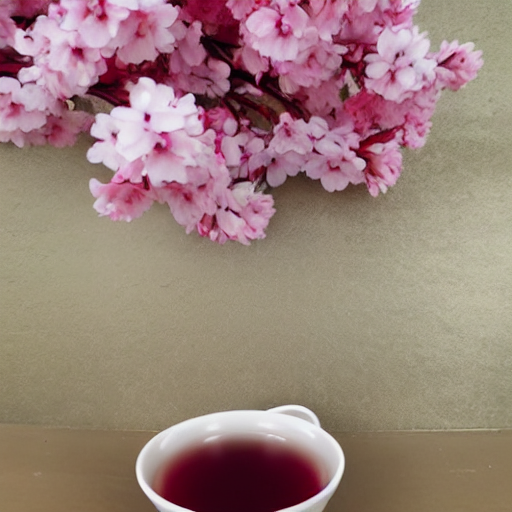What kind of flowers are these, and do they symbolize anything? The flowers in the image appear to be cherry blossoms. In various cultures, particularly in Japan, cherry blossoms symbolize the transient nature of life, as they bloom brilliantly but only for a short duration. Why might someone pair these flowers with a cup of tea? Pairing cherry blossoms with a cup of tea could suggest a theme of relaxation and appreciation of the moment, aligning with the cultural practice of enjoying the serene and fleeting beauty of the blossoms, often while partaking in peaceful activities like tea drinking. 